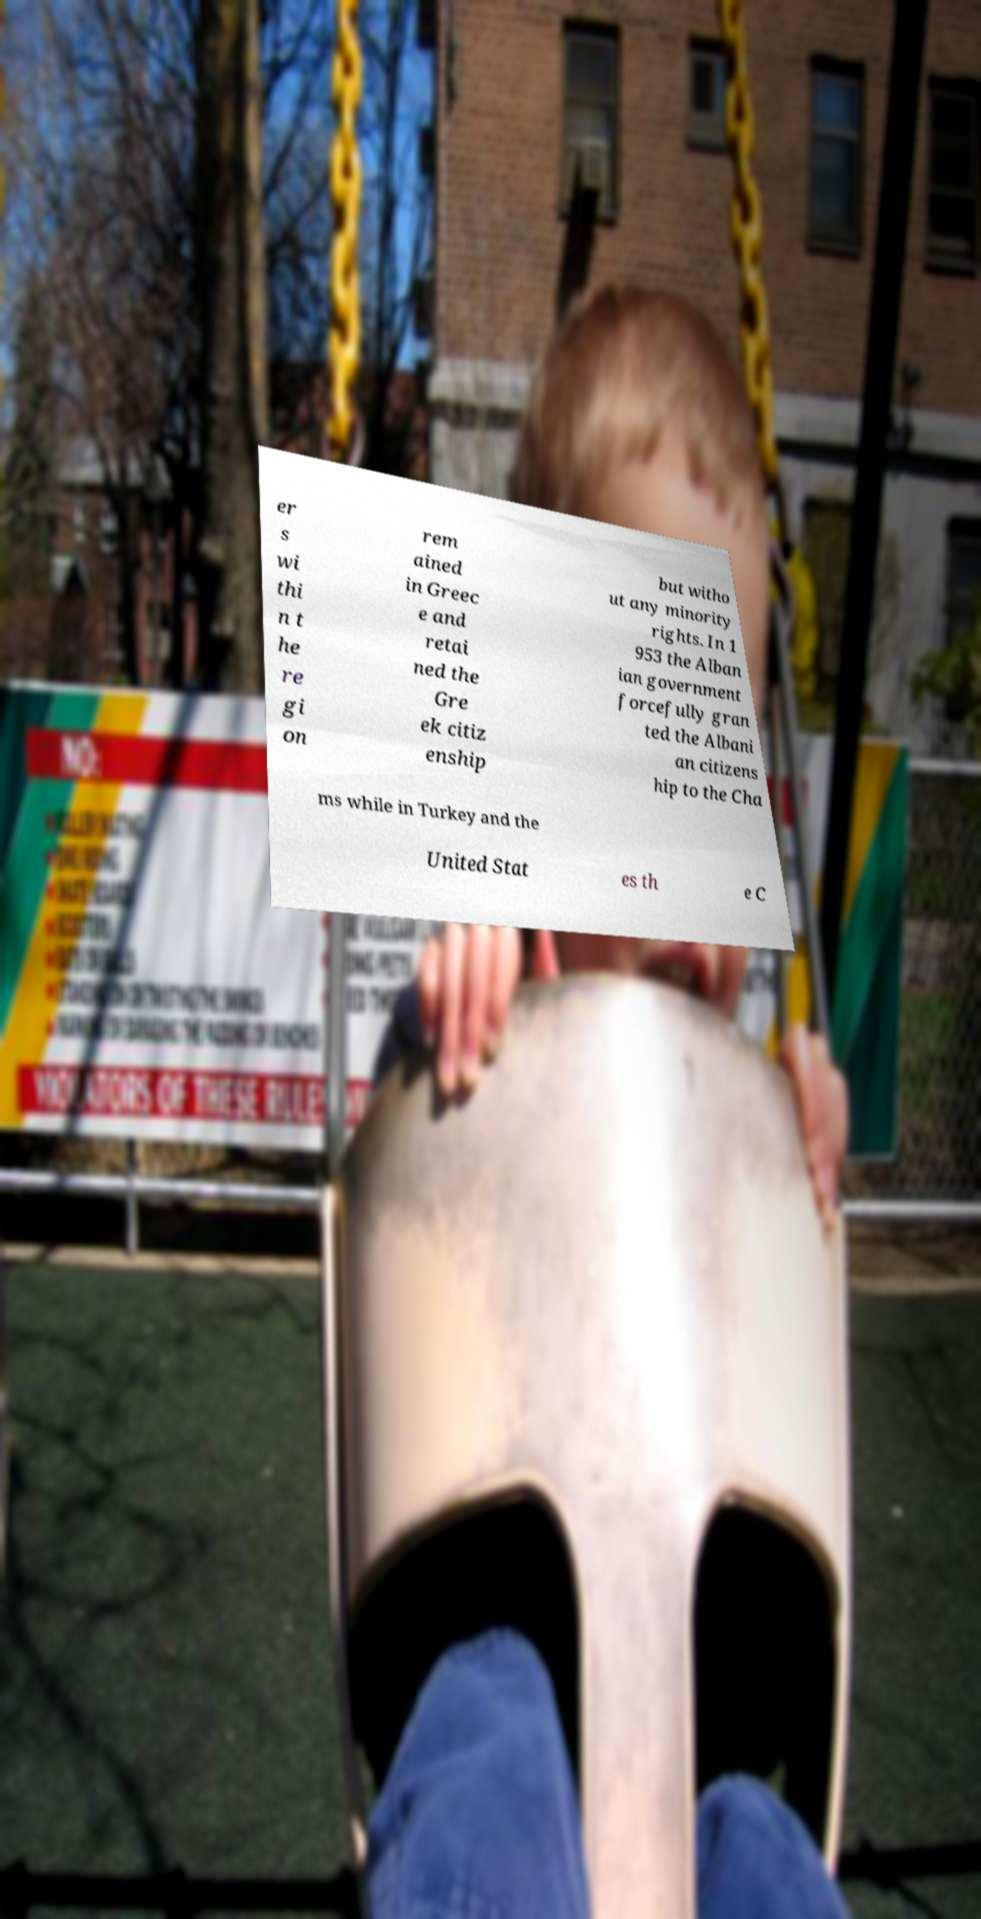Please identify and transcribe the text found in this image. er s wi thi n t he re gi on rem ained in Greec e and retai ned the Gre ek citiz enship but witho ut any minority rights. In 1 953 the Alban ian government forcefully gran ted the Albani an citizens hip to the Cha ms while in Turkey and the United Stat es th e C 